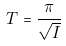<formula> <loc_0><loc_0><loc_500><loc_500>T = \frac { \pi } { \sqrt { I } }</formula> 